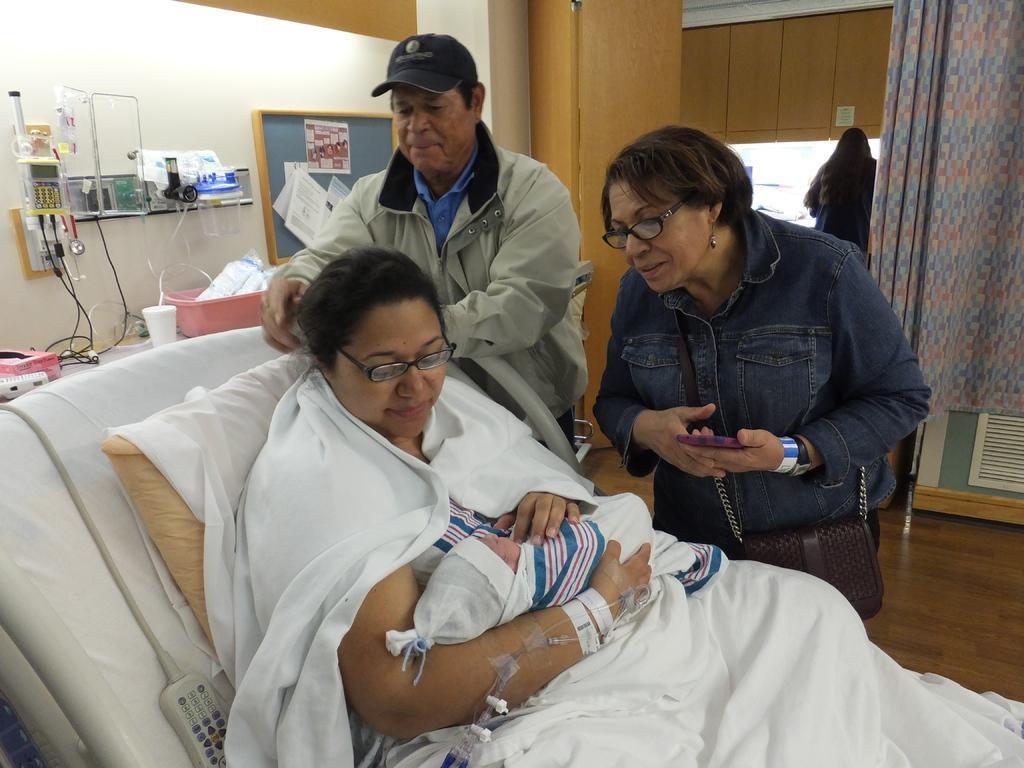Describe this image in one or two sentences. In this image I can see a woman sleeping on the bed and holding a baby in her hand. I can see white colored clothes on her and I can see a pillow which is white in color. I can see a woman wearing blue jacket and a bag is standing and holding a mobile and a man wearing cap, cream jacket and blue shirt is standing. In the background I can see the white colored wall, a board attached to the wall, a woman standing, the curtain and some wooden furniture. 